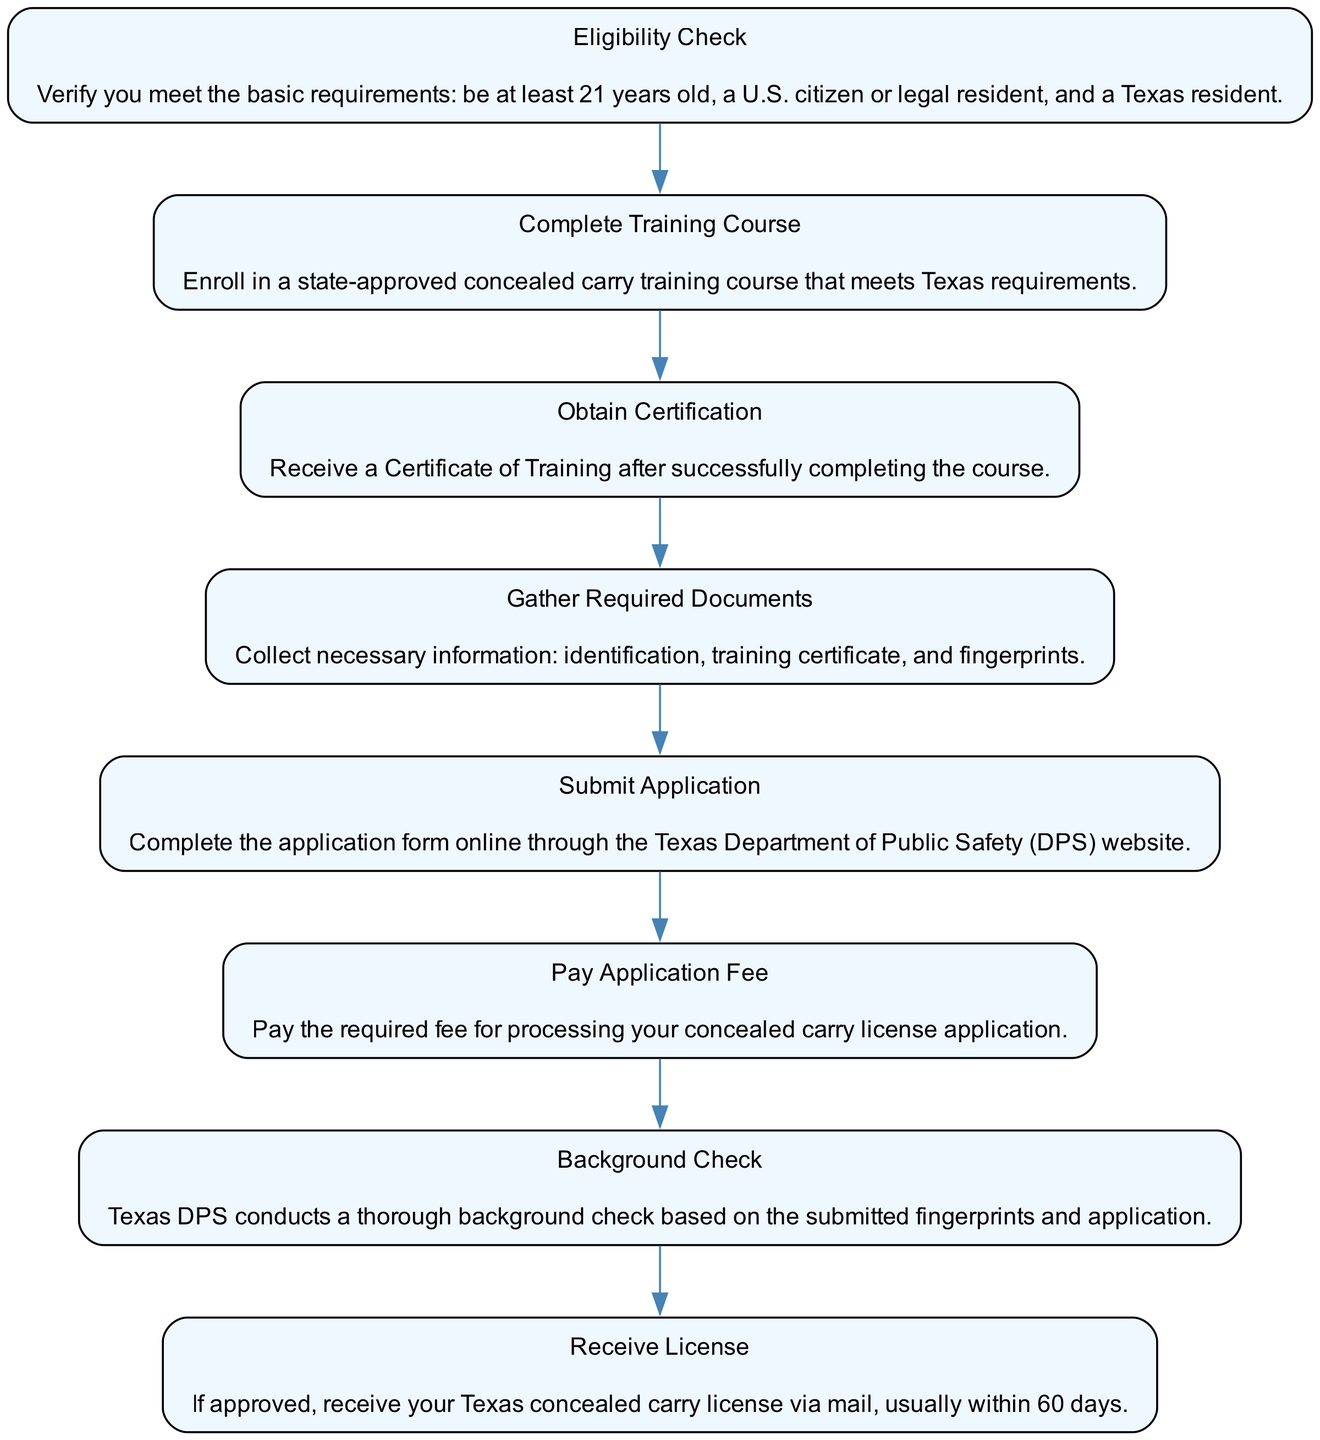What is the first step in the process? The first step shown in the flowchart is the "Eligibility Check," which verifies that the applicant meets the basic requirements.
Answer: Eligibility Check How many nodes are in the diagram? The diagram includes a total of eight nodes, each representing a step in the process of obtaining a Texas concealed carry license.
Answer: Eight What certification must be obtained after the training course? The required certification obtained after completing the training course is the "Certificate of Training."
Answer: Certificate of Training What is required after gathering the necessary documents? After gathering the necessary documents, the next step is to "Submit Application." This follows the document collection step in the flowchart.
Answer: Submit Application What follows the background check? The "Receive License" step follows the background check; if the application is approved, the license is sent.
Answer: Receive License What is the last step in the process? The last step in the flowchart is the "Receive License," which indicates that an approved applicant will receive their license via mail.
Answer: Receive License What step must be completed before submitting the application? The step to be completed before submitting the application is "Gather Required Documents," as it is necessary to have all required paperwork ready.
Answer: Gather Required Documents How long does it usually take to receive the license after approval? It usually takes about 60 days to receive the Texas concealed carry license after approval.
Answer: 60 days 